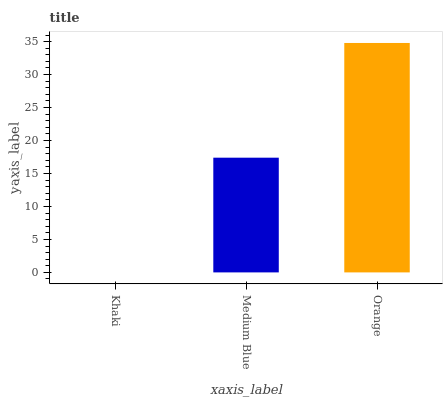Is Khaki the minimum?
Answer yes or no. Yes. Is Orange the maximum?
Answer yes or no. Yes. Is Medium Blue the minimum?
Answer yes or no. No. Is Medium Blue the maximum?
Answer yes or no. No. Is Medium Blue greater than Khaki?
Answer yes or no. Yes. Is Khaki less than Medium Blue?
Answer yes or no. Yes. Is Khaki greater than Medium Blue?
Answer yes or no. No. Is Medium Blue less than Khaki?
Answer yes or no. No. Is Medium Blue the high median?
Answer yes or no. Yes. Is Medium Blue the low median?
Answer yes or no. Yes. Is Orange the high median?
Answer yes or no. No. Is Orange the low median?
Answer yes or no. No. 